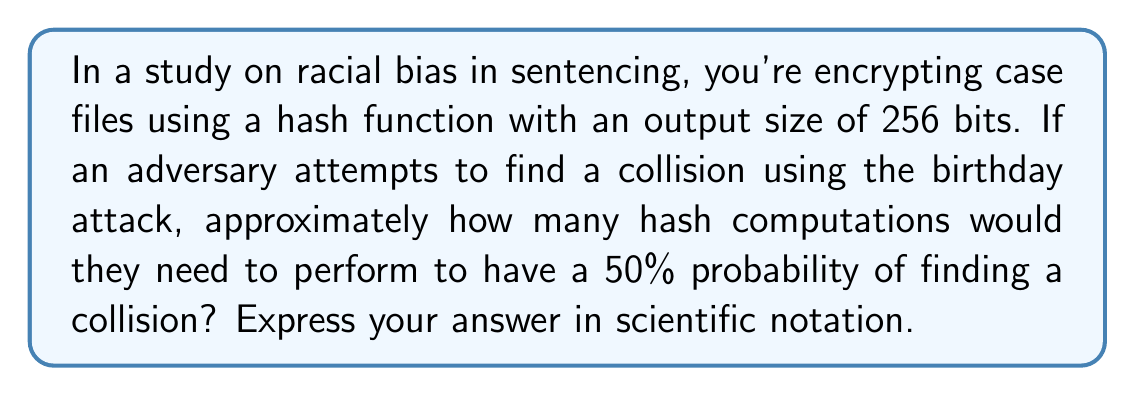Help me with this question. To solve this problem, we'll use the birthday paradox and its application to hash function collisions:

1) The birthday paradox states that for a 50% chance of collision, we need approximately:

   $$\sqrt{2^n}$$ hash computations, where n is the number of bits in the hash output.

2) In this case, n = 256 bits.

3) Substituting this into our formula:

   $$\sqrt{2^{256}}$$

4) This can be simplified to:

   $$2^{128}$$

5) To express this in scientific notation, we need to convert 2^128 to base 10:

   $$2^{128} \approx 3.4028 \times 10^{38}$$

Therefore, an adversary would need to perform approximately 3.4028 × 10^38 hash computations to have a 50% chance of finding a collision in this 256-bit hash function.
Answer: $3.4 \times 10^{38}$ 